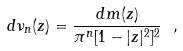Convert formula to latex. <formula><loc_0><loc_0><loc_500><loc_500>d \nu _ { n } ( z ) = \frac { d m ( z ) } { \pi ^ { n } [ 1 - | z | ^ { 2 } ] ^ { 2 } } \ ,</formula> 